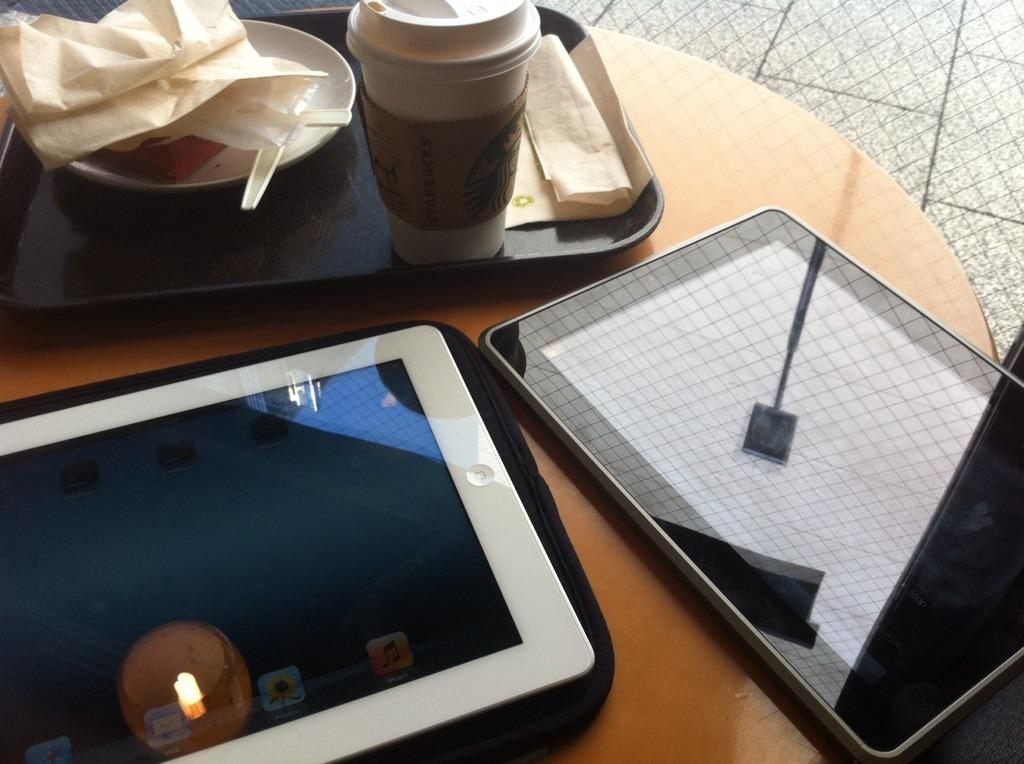How many iPads can be seen in the image? There are two iPads in the image. What is the tray used for in the image? The tray is used to hold or organize objects in the image. What is the glass used for in the image? The glass is likely used for holding a beverage. What is on the plate in the image? The plate may hold food or other items. What is the purpose of the paper in the image? The paper could be used for writing, drawing, or holding information. Where are all the objects located in the image? All objects are on a table in the image. Can you see a boat in the image? No, there is no boat present in the image. How many books are on the table in the image? There are no books visible in the image. 